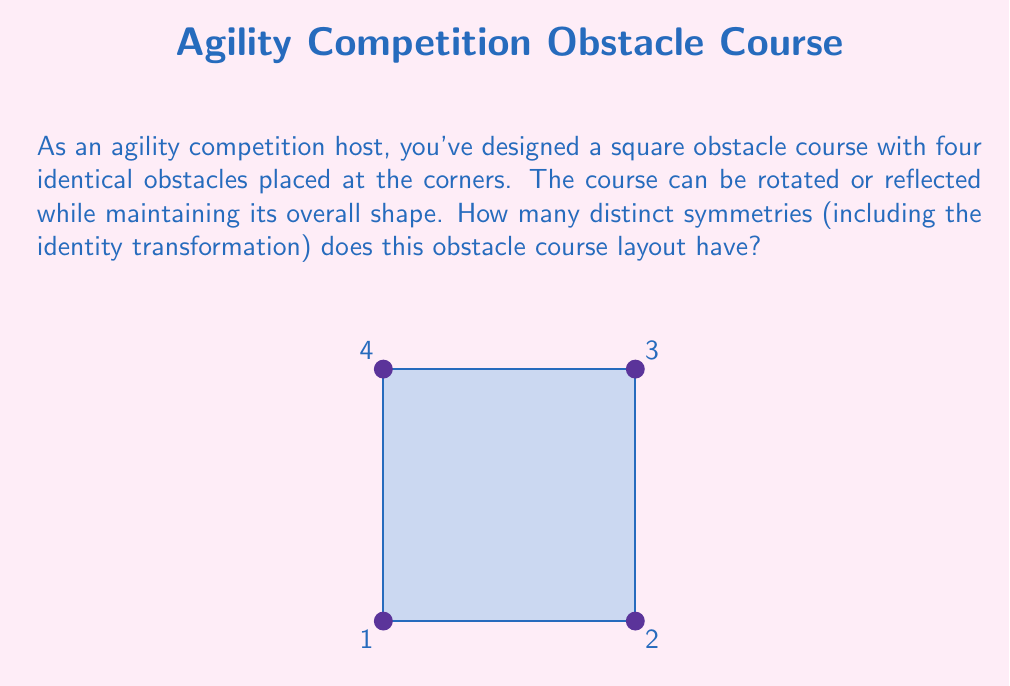Could you help me with this problem? To solve this problem, we need to consider the symmetry group of a square, which is known as the dihedral group $D_4$. Let's break down the symmetries:

1) Identity transformation (1 symmetry):
   - Leaving the square unchanged

2) Rotations (3 symmetries):
   - Rotating 90° clockwise
   - Rotating 180°
   - Rotating 270° clockwise (or 90° counterclockwise)

3) Reflections (4 symmetries):
   - Reflecting across the vertical axis
   - Reflecting across the horizontal axis
   - Reflecting across the diagonal from top-left to bottom-right
   - Reflecting across the diagonal from top-right to bottom-left

To count the total number of symmetries, we sum up all these transformations:

$$\text{Total symmetries} = 1 + 3 + 4 = 8$$

This result is consistent with the order of the dihedral group $D_4$, which is given by the formula $|D_n| = 2n$, where $n$ is the number of sides of the regular polygon. In this case, $n = 4$, so $|D_4| = 2(4) = 8$.

Each of these symmetries represents a unique configuration of the obstacle course that can be achieved through rotation or reflection, while maintaining the overall square shape and the relative positions of the obstacles.
Answer: 8 